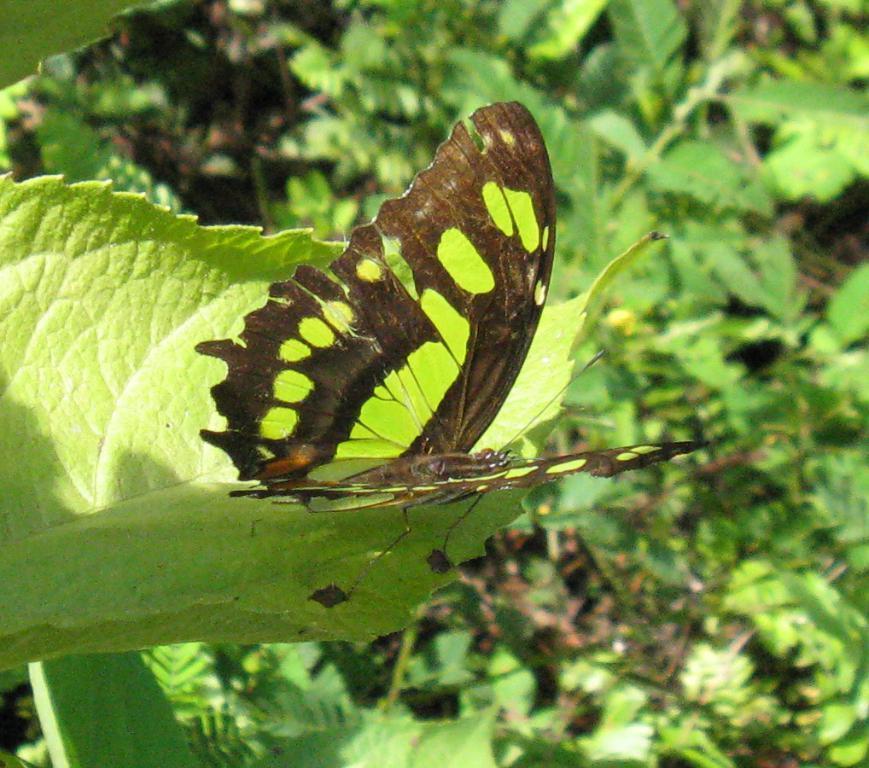In one or two sentences, can you explain what this image depicts? In this picture, we see the butterfly is on the green leaf. This butterfly is in brown and green color. There are trees in the background and this picture is blurred in the background. 